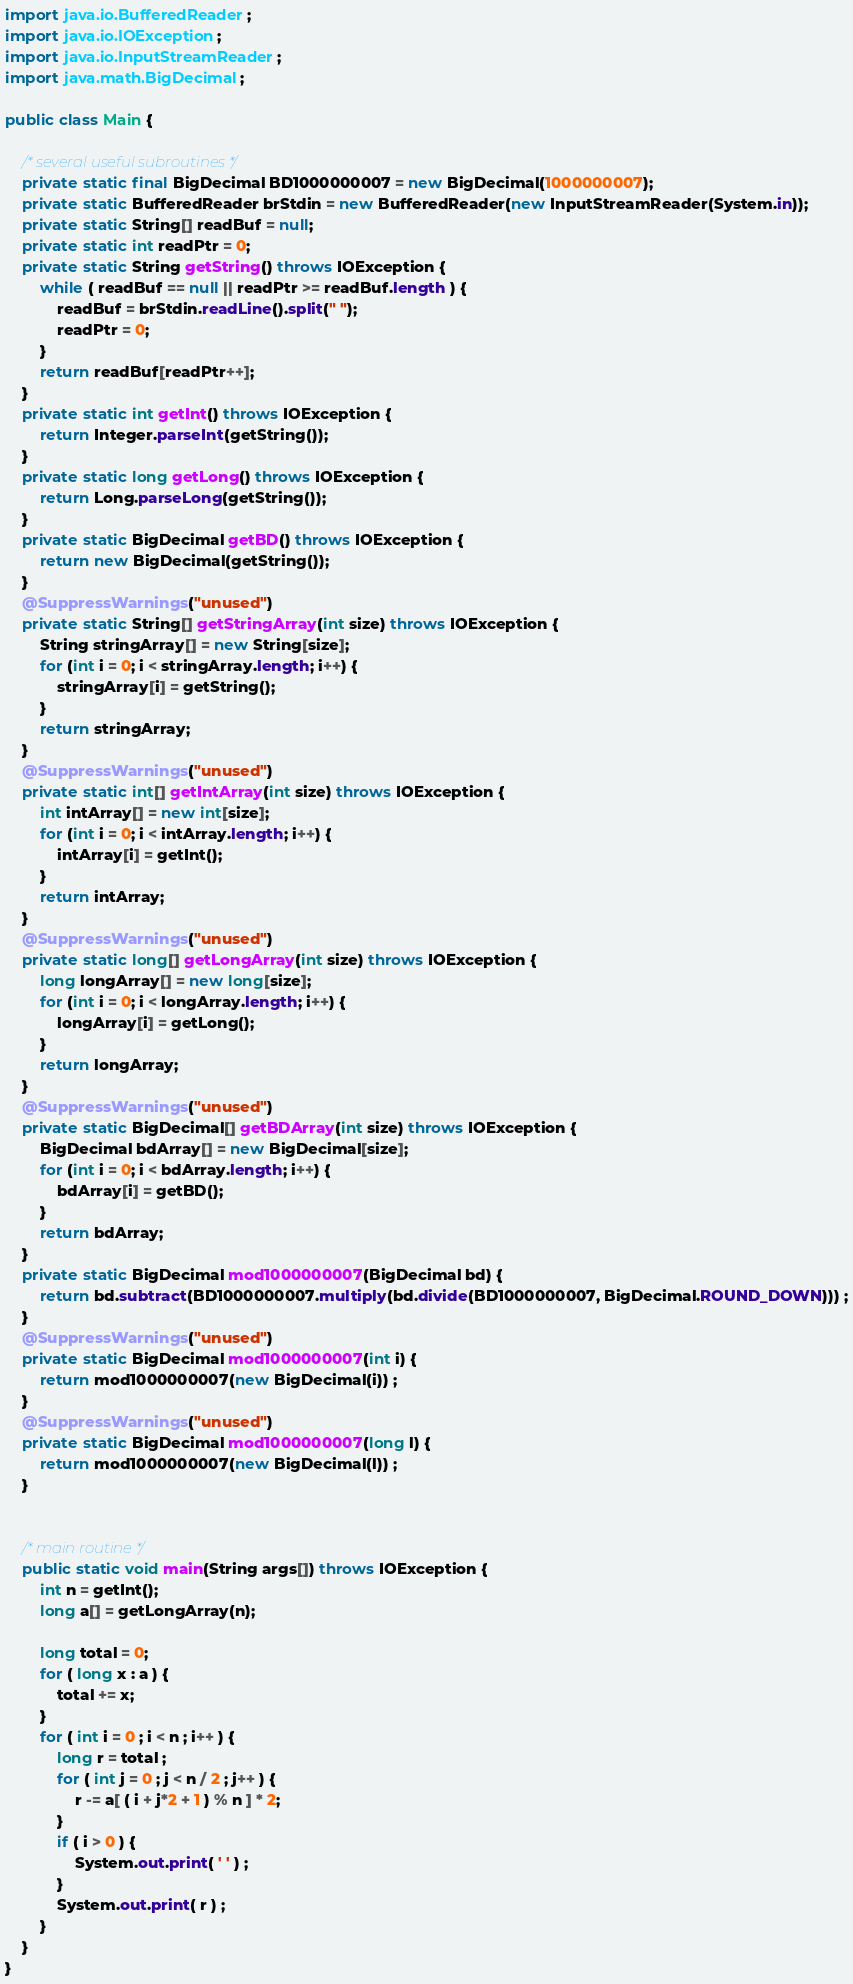Convert code to text. <code><loc_0><loc_0><loc_500><loc_500><_Java_>import java.io.BufferedReader;
import java.io.IOException;
import java.io.InputStreamReader;
import java.math.BigDecimal;

public class Main {

	/* several useful subroutines */
	private static final BigDecimal BD1000000007 = new BigDecimal(1000000007);
	private static BufferedReader brStdin = new BufferedReader(new InputStreamReader(System.in));
	private static String[] readBuf = null;
	private static int readPtr = 0;
	private static String getString() throws IOException {
		while ( readBuf == null || readPtr >= readBuf.length ) {
			readBuf = brStdin.readLine().split(" ");
			readPtr = 0;
		}
		return readBuf[readPtr++];
	}
	private static int getInt() throws IOException {
		return Integer.parseInt(getString());
	}
	private static long getLong() throws IOException {
		return Long.parseLong(getString());
	}
	private static BigDecimal getBD() throws IOException {
		return new BigDecimal(getString());
	}
	@SuppressWarnings("unused")
	private static String[] getStringArray(int size) throws IOException {
		String stringArray[] = new String[size];
		for (int i = 0; i < stringArray.length; i++) {
			stringArray[i] = getString();
		}
		return stringArray;
	}
	@SuppressWarnings("unused")
	private static int[] getIntArray(int size) throws IOException {
		int intArray[] = new int[size];
		for (int i = 0; i < intArray.length; i++) {
			intArray[i] = getInt();
		}
		return intArray;
	}
	@SuppressWarnings("unused")
	private static long[] getLongArray(int size) throws IOException {
		long longArray[] = new long[size];
		for (int i = 0; i < longArray.length; i++) {
			longArray[i] = getLong();
		}
		return longArray;
	}
	@SuppressWarnings("unused")
	private static BigDecimal[] getBDArray(int size) throws IOException {
		BigDecimal bdArray[] = new BigDecimal[size];
		for (int i = 0; i < bdArray.length; i++) {
			bdArray[i] = getBD();
		}
		return bdArray;
	}
	private static BigDecimal mod1000000007(BigDecimal bd) {
		return bd.subtract(BD1000000007.multiply(bd.divide(BD1000000007, BigDecimal.ROUND_DOWN))) ;
	}
	@SuppressWarnings("unused")
	private static BigDecimal mod1000000007(int i) {
		return mod1000000007(new BigDecimal(i)) ;
	}
	@SuppressWarnings("unused")
	private static BigDecimal mod1000000007(long l) {
		return mod1000000007(new BigDecimal(l)) ;
	}

	
	/* main routine */
	public static void main(String args[]) throws IOException {
		int n = getInt();
		long a[] = getLongArray(n);

		long total = 0;
		for ( long x : a ) {
			total += x;
		}
		for ( int i = 0 ; i < n ; i++ ) {
			long r = total ;
			for ( int j = 0 ; j < n / 2 ; j++ ) {
				r -= a[ ( i + j*2 + 1 ) % n ] * 2;
			}
			if ( i > 0 ) {
				System.out.print( ' ' ) ;
			}
			System.out.print( r ) ;
		}
	}
}
</code> 